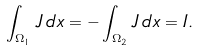<formula> <loc_0><loc_0><loc_500><loc_500>\int _ { \Omega _ { 1 } } J \, d x = - \int _ { \Omega _ { 2 } } J \, d x = I .</formula> 